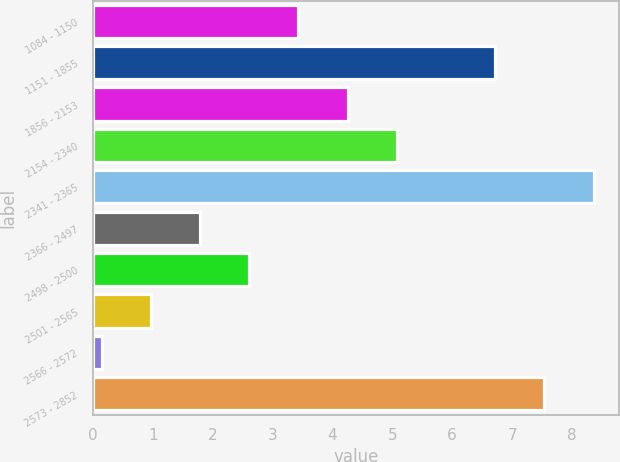Convert chart. <chart><loc_0><loc_0><loc_500><loc_500><bar_chart><fcel>1084 - 1150<fcel>1151 - 1855<fcel>1856 - 2153<fcel>2154 - 2340<fcel>2341 - 2365<fcel>2366 - 2497<fcel>2498 - 2500<fcel>2501 - 2565<fcel>2566 - 2572<fcel>2573 - 2852<nl><fcel>3.43<fcel>6.71<fcel>4.25<fcel>5.07<fcel>8.37<fcel>1.79<fcel>2.61<fcel>0.97<fcel>0.15<fcel>7.53<nl></chart> 